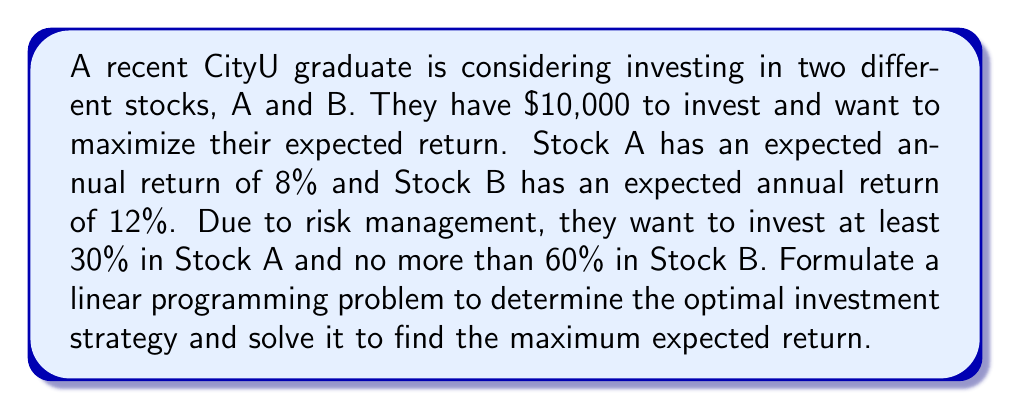Solve this math problem. Let's approach this step-by-step:

1) Define variables:
   Let $x$ be the amount invested in Stock A
   Let $y$ be the amount invested in Stock B

2) Objective function:
   Maximize $Z = 0.08x + 0.12y$ (expected return)

3) Constraints:
   a) Total investment: $x + y = 10000$
   b) At least 30% in Stock A: $x \geq 0.3(10000) = 3000$
   c) No more than 60% in Stock B: $y \leq 0.6(10000) = 6000$
   d) Non-negativity: $x \geq 0, y \geq 0$

4) Linear Programming Problem:
   Maximize $Z = 0.08x + 0.12y$
   Subject to:
   $x + y = 10000$
   $x \geq 3000$
   $y \leq 6000$
   $x \geq 0, y \geq 0$

5) Solve using the corner point method:
   Possible corner points are (3000, 7000), (4000, 6000), and (6000, 4000)

6) Evaluate Z at each point:
   At (3000, 7000): $Z = 0.08(3000) + 0.12(7000) = 1080$
   At (4000, 6000): $Z = 0.08(4000) + 0.12(6000) = 1040$
   At (6000, 4000): $Z = 0.08(6000) + 0.12(4000) = 960$

7) The maximum Z occurs at (3000, 7000)

Therefore, the optimal strategy is to invest $3000 in Stock A and $7000 in Stock B, yielding a maximum expected return of $1080 or 10.8%.
Answer: Invest $3000 in Stock A and $7000 in Stock B for a maximum expected return of $1080 (10.8%). 